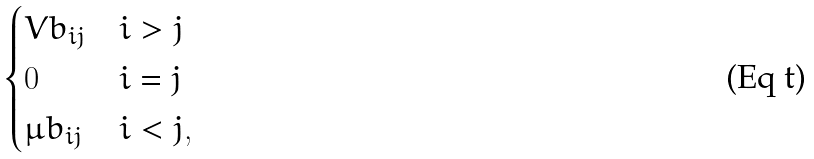<formula> <loc_0><loc_0><loc_500><loc_500>\begin{cases} V b _ { i j } & i > j \\ 0 & i = j \\ \mu b _ { i j } & i < j , \end{cases}</formula> 